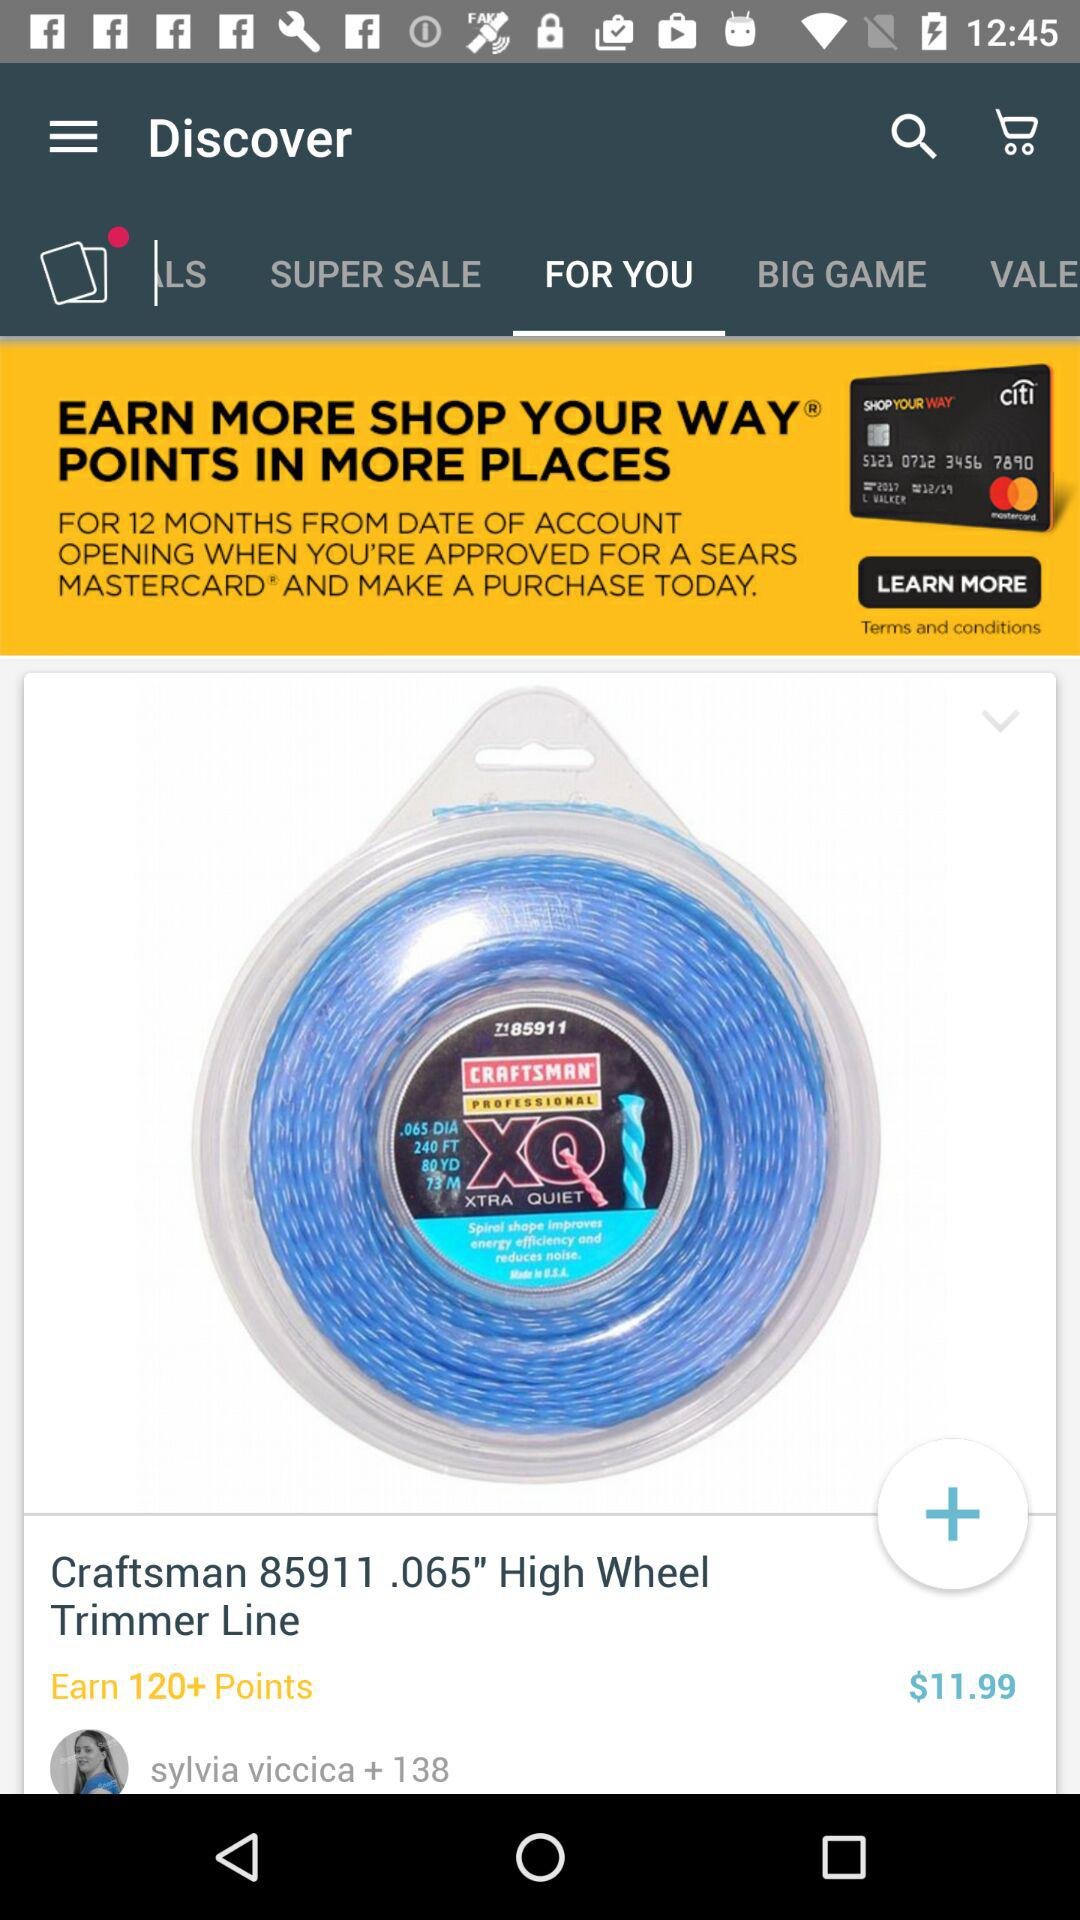How much is the product?
Answer the question using a single word or phrase. $11.99 